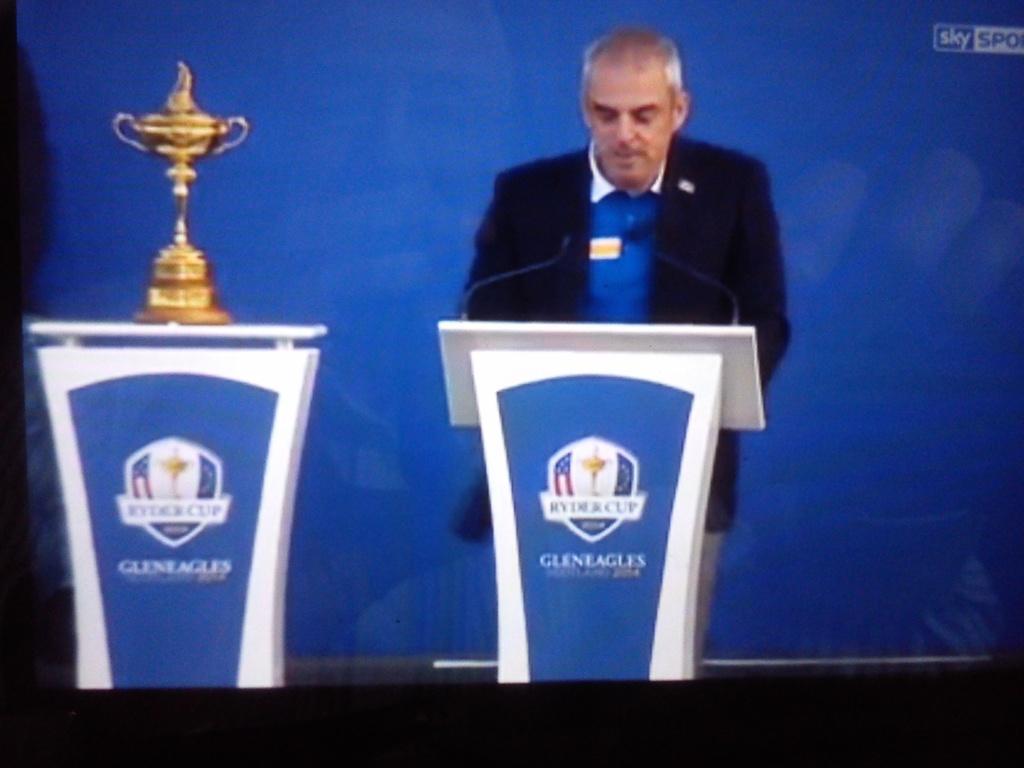How would you summarize this image in a sentence or two? In this image we can see a person standing. And we can see the microphones. And we can see the podium. And we can see a trophy on the podium. And we can see the blue colored board/banner with some text on it. 